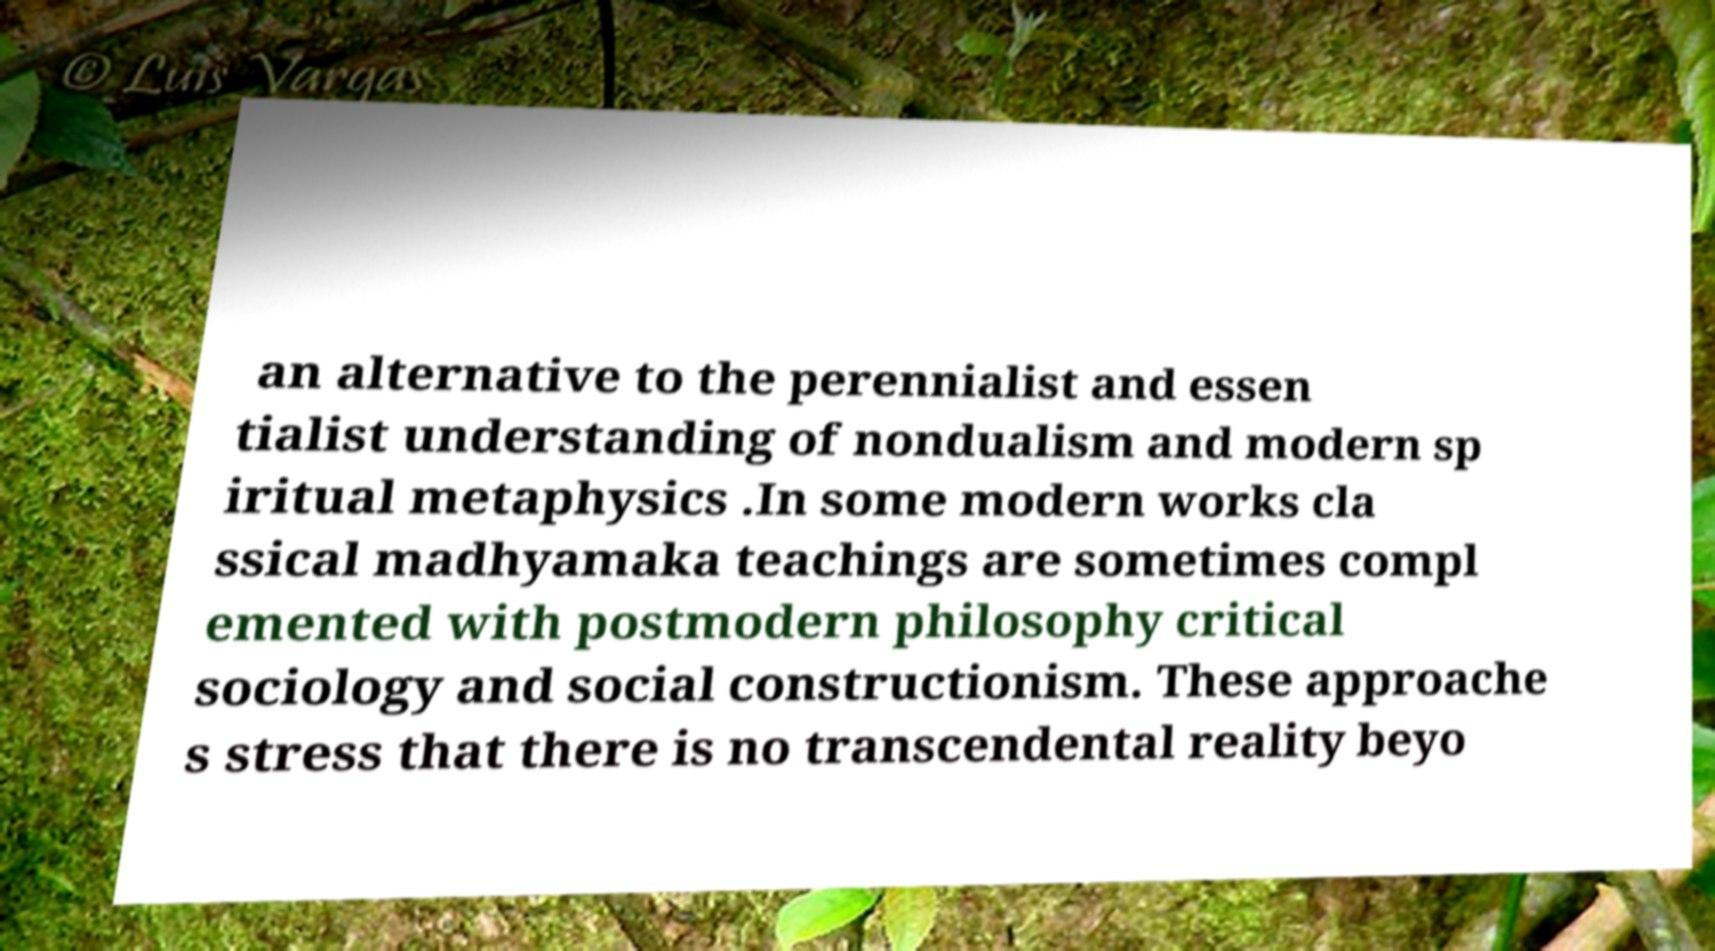Can you accurately transcribe the text from the provided image for me? an alternative to the perennialist and essen tialist understanding of nondualism and modern sp iritual metaphysics .In some modern works cla ssical madhyamaka teachings are sometimes compl emented with postmodern philosophy critical sociology and social constructionism. These approache s stress that there is no transcendental reality beyo 